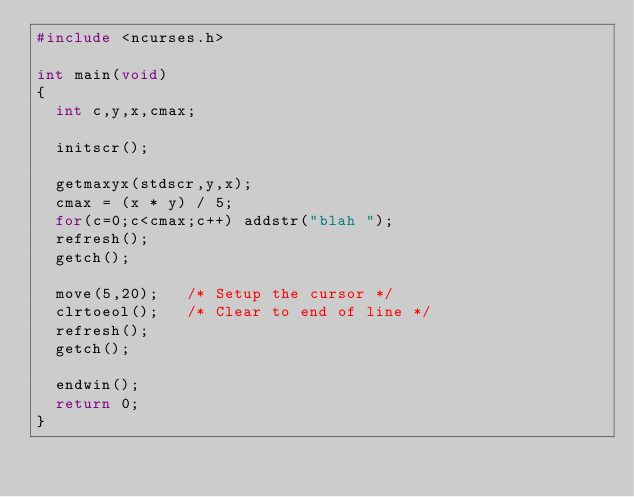Convert code to text. <code><loc_0><loc_0><loc_500><loc_500><_C_>#include <ncurses.h>

int main(void)
{
	int c,y,x,cmax;

	initscr();
		
	getmaxyx(stdscr,y,x);
	cmax = (x * y) / 5;
	for(c=0;c<cmax;c++) addstr("blah ");
	refresh();
	getch();

	move(5,20);		/* Setup the cursor */
	clrtoeol();		/* Clear to end of line */
	refresh();
	getch();

	endwin();
	return 0;
}

</code> 